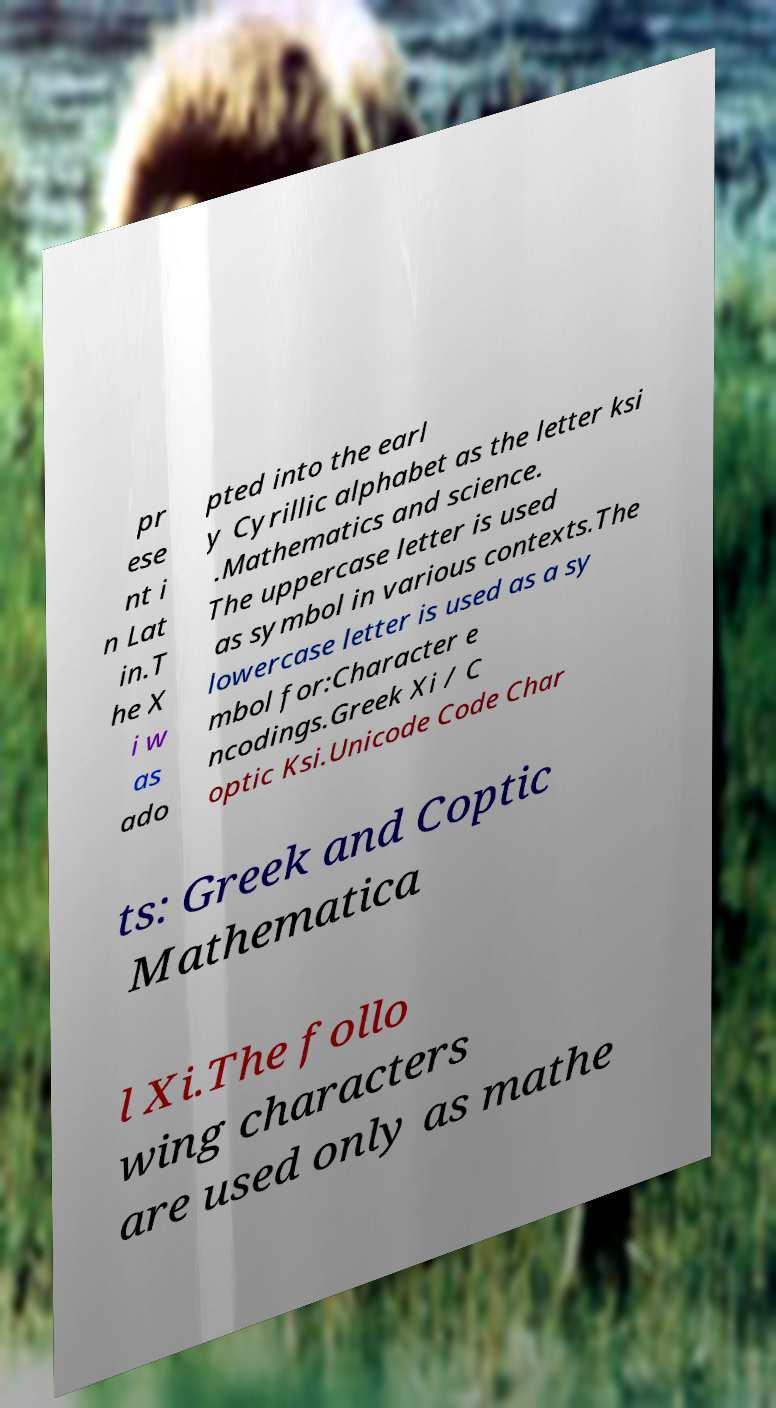Please identify and transcribe the text found in this image. pr ese nt i n Lat in.T he X i w as ado pted into the earl y Cyrillic alphabet as the letter ksi .Mathematics and science. The uppercase letter is used as symbol in various contexts.The lowercase letter is used as a sy mbol for:Character e ncodings.Greek Xi / C optic Ksi.Unicode Code Char ts: Greek and Coptic Mathematica l Xi.The follo wing characters are used only as mathe 